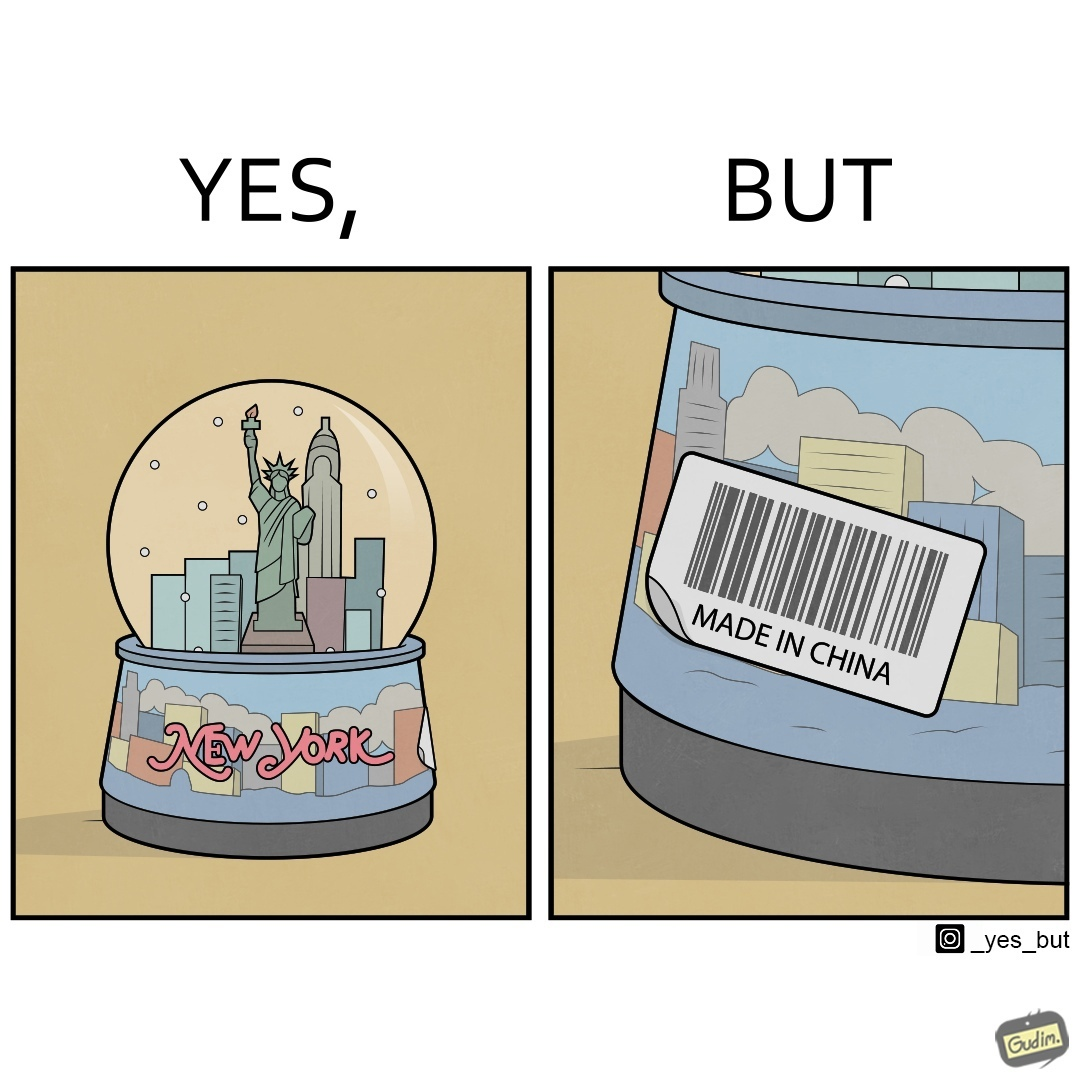Describe what you see in the left and right parts of this image. In the left part of the image: A snowglobe that says 'New York' In the right part of the image: Made in china' label on the snowglobe 